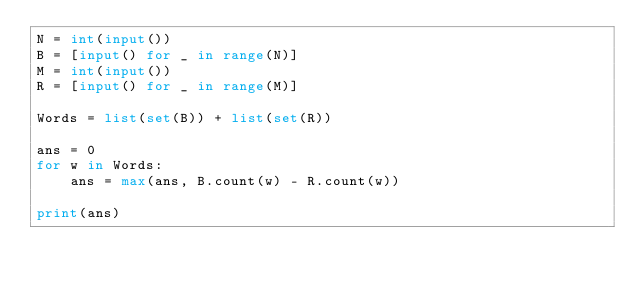Convert code to text. <code><loc_0><loc_0><loc_500><loc_500><_Python_>N = int(input())
B = [input() for _ in range(N)]
M = int(input())
R = [input() for _ in range(M)]

Words = list(set(B)) + list(set(R))

ans = 0
for w in Words:
	ans = max(ans, B.count(w) - R.count(w))

print(ans)
</code> 